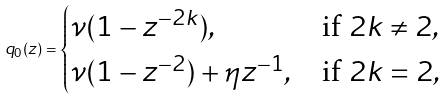<formula> <loc_0><loc_0><loc_500><loc_500>q _ { 0 } ( z ) = \begin{cases} \nu ( 1 - z ^ { - 2 k } ) , & \text {if } 2 k \neq 2 , \\ \nu ( 1 - z ^ { - 2 } ) + \eta z ^ { - 1 } , & \text {if } 2 k = 2 , \end{cases}</formula> 